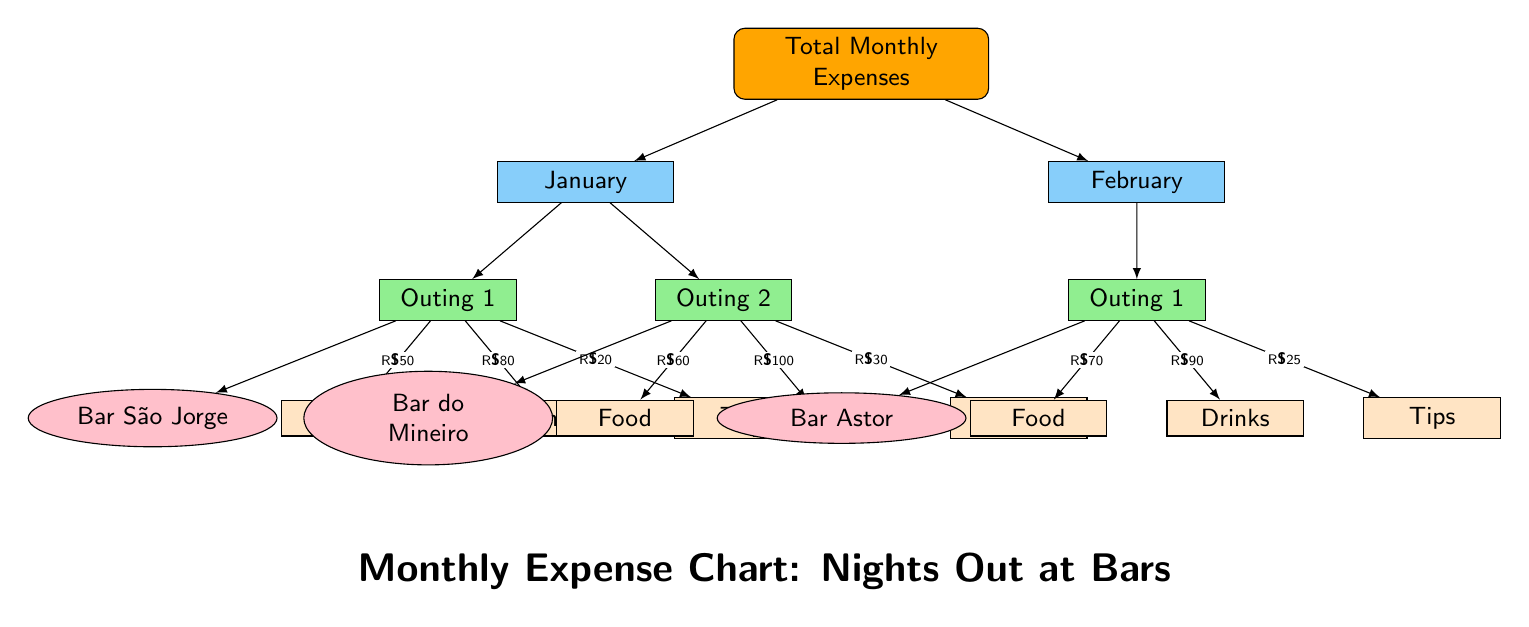What's the total expense for January? The total monthly expense for January is found by adding the expenses of both outings in that month. The expenses for Outing 1 at Bar São Jorge are R\$50 (Food) + R\$80 (Drinks) + R\$20 (Tips) = R\$150. The expenses for Outing 2 at Bar do Mineiro are R\$60 (Food) + R\$100 (Drinks) + R\$30 (Tips) = R\$190. Therefore, the total for January is R\$150 + R\$190 = R\$340.
Answer: R\$340 How many outings are recorded for February? February has one outing recorded, indicated as "Outing 1." The diagram specifically shows the details for that outing and does not list any additional outings for this month.
Answer: 1 outing What is the cost of drinks for Outing 2 in January? The cost of drinks for Outing 2 at Bar do Mineiro is specifically listed in the diagram as R\$100. This value is contained in the node under Outing 2.
Answer: R\$100 Which location had the highest total expenses in January? To determine which location had the highest total expenses in January, we compare the totals for each outing. Outing 1 at Bar São Jorge totaled R\$150, while Outing 2 at Bar do Mineiro totaled R\$190. Therefore, Bar do Mineiro had the highest total expenses in January with R\$190.
Answer: Bar do Mineiro What is the breakdown of expenses for Outing 1 in February? The breakdown of expenses for Outing 1 at Bar Astor in February includes Food for R\$70, Drinks for R\$90, and Tips for R\$25. Each of these expenses is clearly listed under the outing in the diagram. Adding these together gives a total of R\$185 for this outing, but the question specifically asks for the breakdown.
Answer: Food: R\$70, Drinks: R\$90, Tips: R\$25 